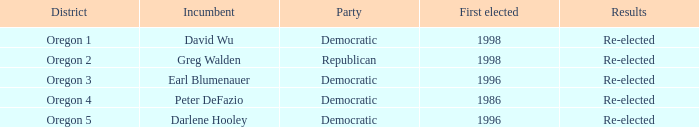Who is the incumbent for the Oregon 5 District that was elected in 1996? Darlene Hooley. Can you give me this table as a dict? {'header': ['District', 'Incumbent', 'Party', 'First elected', 'Results'], 'rows': [['Oregon 1', 'David Wu', 'Democratic', '1998', 'Re-elected'], ['Oregon 2', 'Greg Walden', 'Republican', '1998', 'Re-elected'], ['Oregon 3', 'Earl Blumenauer', 'Democratic', '1996', 'Re-elected'], ['Oregon 4', 'Peter DeFazio', 'Democratic', '1986', 'Re-elected'], ['Oregon 5', 'Darlene Hooley', 'Democratic', '1996', 'Re-elected']]} 